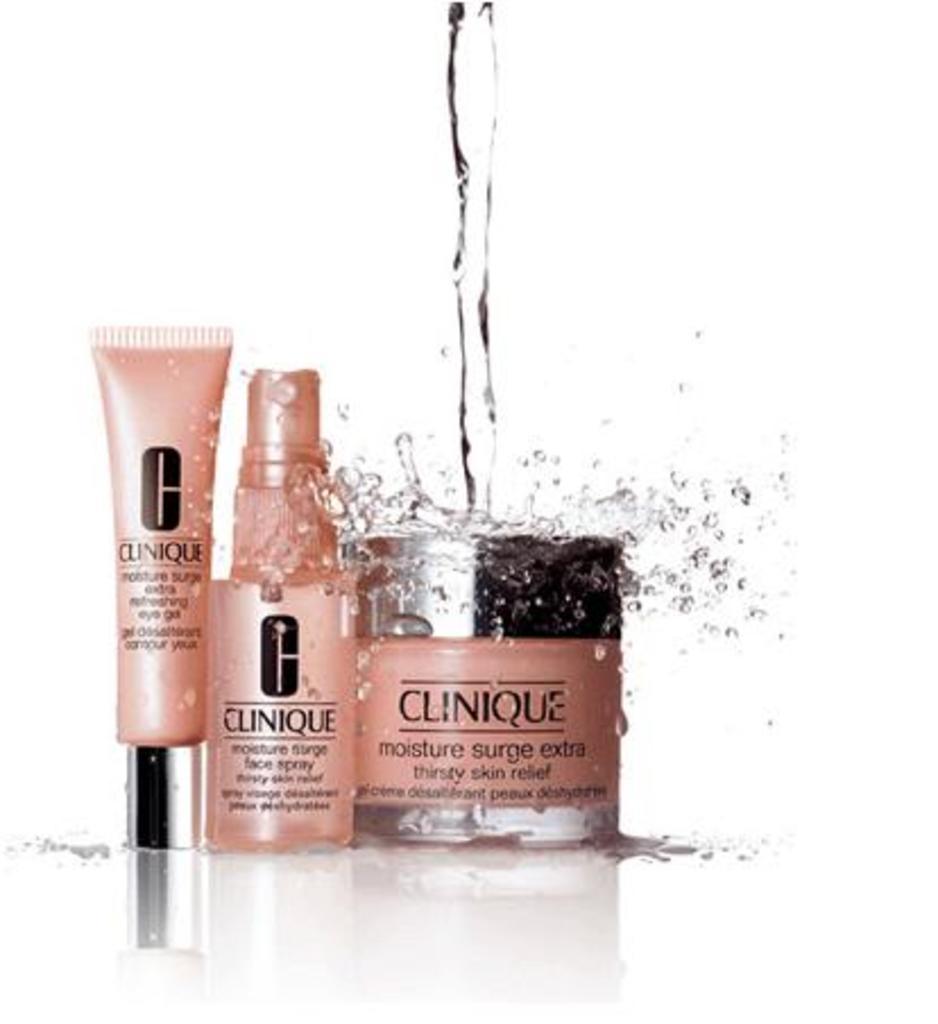In one or two sentences, can you explain what this image depicts? As we can see in the image, there are cosmetic items and water is poured on these items. 